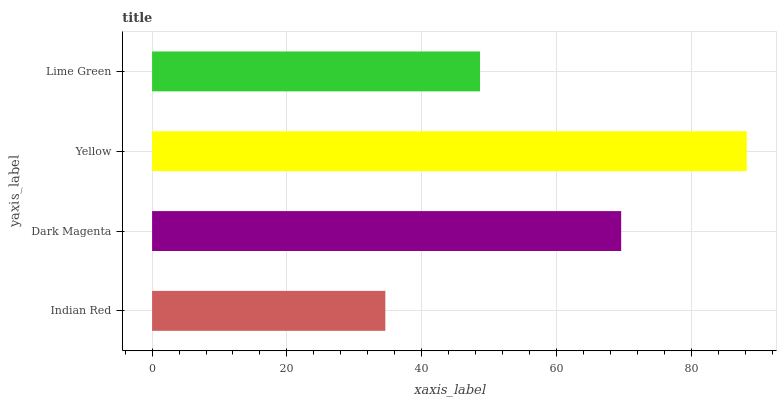Is Indian Red the minimum?
Answer yes or no. Yes. Is Yellow the maximum?
Answer yes or no. Yes. Is Dark Magenta the minimum?
Answer yes or no. No. Is Dark Magenta the maximum?
Answer yes or no. No. Is Dark Magenta greater than Indian Red?
Answer yes or no. Yes. Is Indian Red less than Dark Magenta?
Answer yes or no. Yes. Is Indian Red greater than Dark Magenta?
Answer yes or no. No. Is Dark Magenta less than Indian Red?
Answer yes or no. No. Is Dark Magenta the high median?
Answer yes or no. Yes. Is Lime Green the low median?
Answer yes or no. Yes. Is Lime Green the high median?
Answer yes or no. No. Is Dark Magenta the low median?
Answer yes or no. No. 